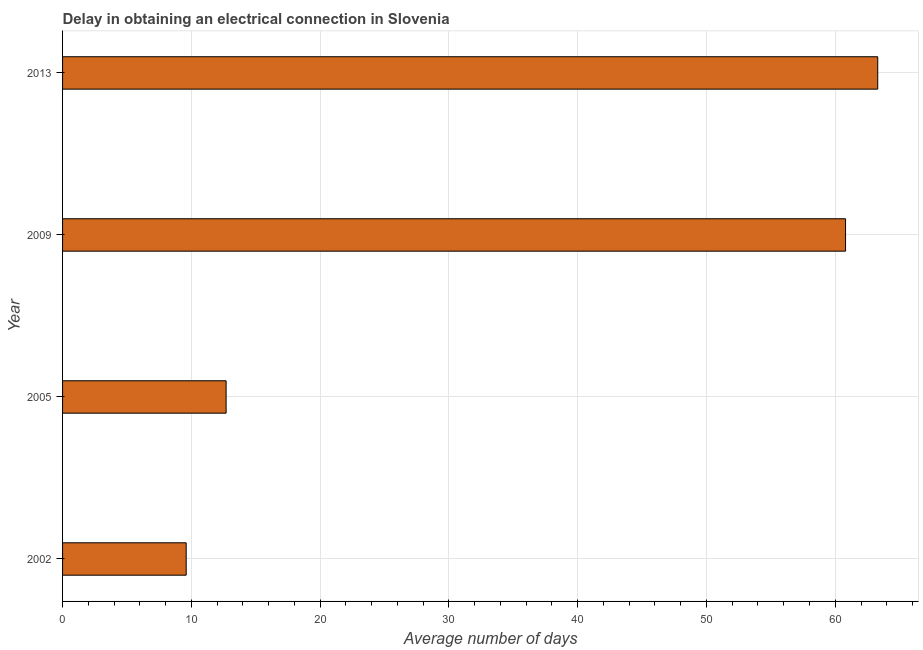Does the graph contain any zero values?
Your answer should be very brief. No. What is the title of the graph?
Ensure brevity in your answer.  Delay in obtaining an electrical connection in Slovenia. What is the label or title of the X-axis?
Offer a terse response. Average number of days. Across all years, what is the maximum dalay in electrical connection?
Keep it short and to the point. 63.3. Across all years, what is the minimum dalay in electrical connection?
Offer a very short reply. 9.6. In which year was the dalay in electrical connection maximum?
Offer a terse response. 2013. What is the sum of the dalay in electrical connection?
Your answer should be compact. 146.4. What is the difference between the dalay in electrical connection in 2002 and 2009?
Your answer should be compact. -51.2. What is the average dalay in electrical connection per year?
Give a very brief answer. 36.6. What is the median dalay in electrical connection?
Make the answer very short. 36.75. What is the ratio of the dalay in electrical connection in 2002 to that in 2005?
Offer a very short reply. 0.76. Is the dalay in electrical connection in 2002 less than that in 2013?
Offer a very short reply. Yes. Is the sum of the dalay in electrical connection in 2002 and 2009 greater than the maximum dalay in electrical connection across all years?
Your answer should be compact. Yes. What is the difference between the highest and the lowest dalay in electrical connection?
Your answer should be very brief. 53.7. What is the Average number of days in 2002?
Offer a terse response. 9.6. What is the Average number of days in 2009?
Make the answer very short. 60.8. What is the Average number of days in 2013?
Provide a succinct answer. 63.3. What is the difference between the Average number of days in 2002 and 2009?
Keep it short and to the point. -51.2. What is the difference between the Average number of days in 2002 and 2013?
Ensure brevity in your answer.  -53.7. What is the difference between the Average number of days in 2005 and 2009?
Give a very brief answer. -48.1. What is the difference between the Average number of days in 2005 and 2013?
Provide a short and direct response. -50.6. What is the ratio of the Average number of days in 2002 to that in 2005?
Keep it short and to the point. 0.76. What is the ratio of the Average number of days in 2002 to that in 2009?
Provide a short and direct response. 0.16. What is the ratio of the Average number of days in 2002 to that in 2013?
Ensure brevity in your answer.  0.15. What is the ratio of the Average number of days in 2005 to that in 2009?
Offer a very short reply. 0.21. What is the ratio of the Average number of days in 2005 to that in 2013?
Provide a succinct answer. 0.2. 